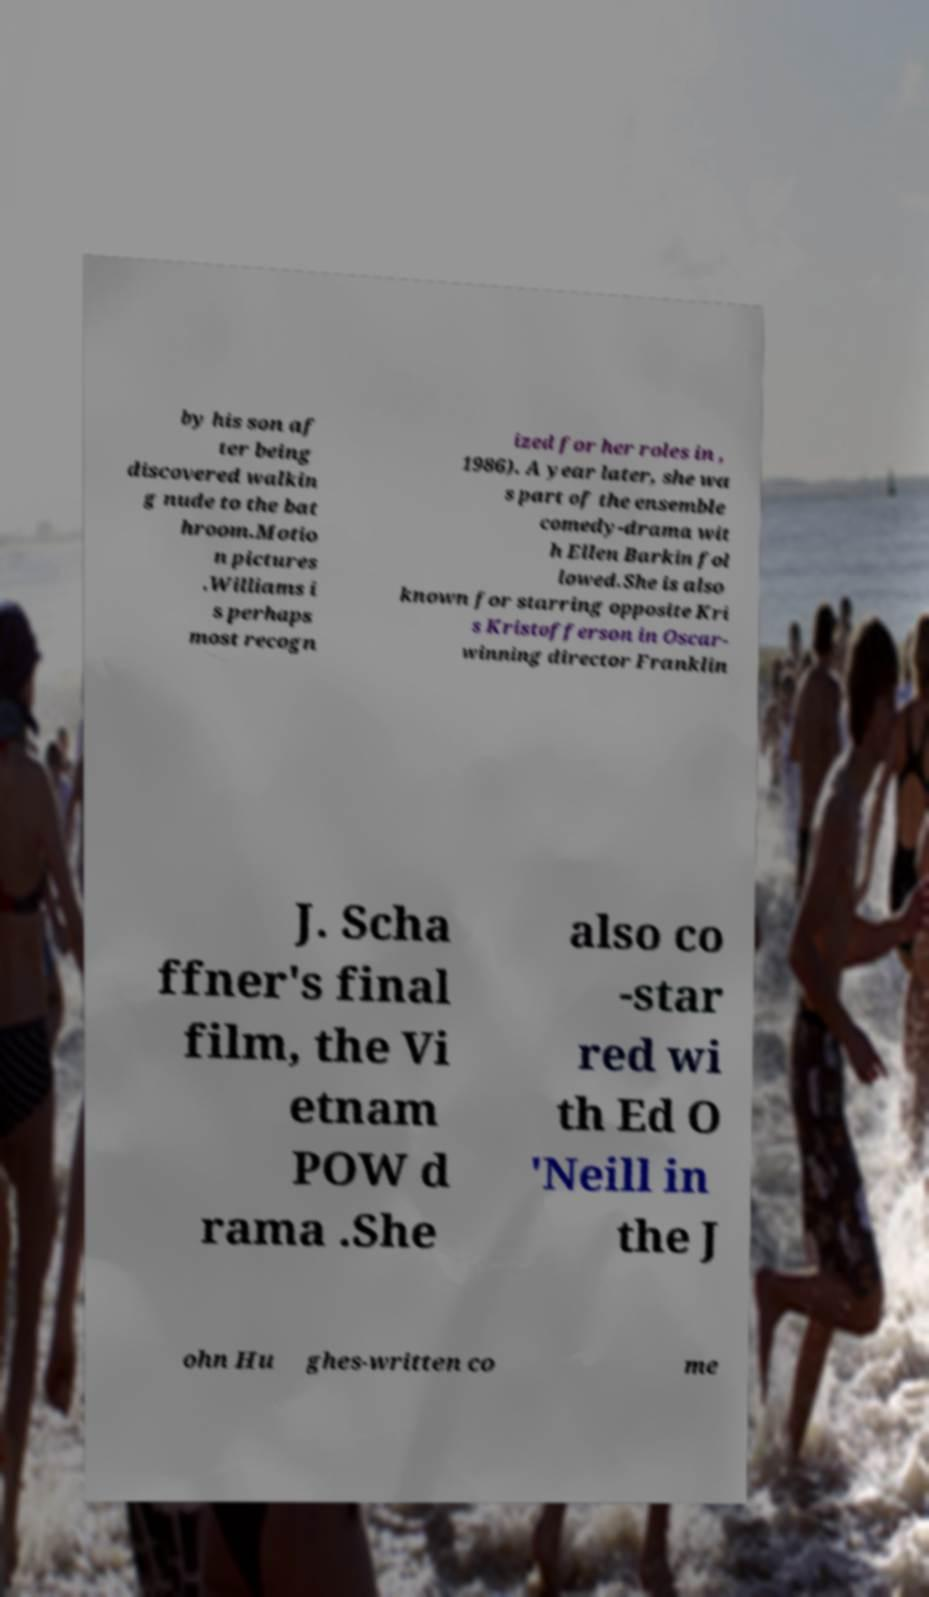Could you assist in decoding the text presented in this image and type it out clearly? by his son af ter being discovered walkin g nude to the bat hroom.Motio n pictures .Williams i s perhaps most recogn ized for her roles in , 1986). A year later, she wa s part of the ensemble comedy-drama wit h Ellen Barkin fol lowed.She is also known for starring opposite Kri s Kristofferson in Oscar- winning director Franklin J. Scha ffner's final film, the Vi etnam POW d rama .She also co -star red wi th Ed O 'Neill in the J ohn Hu ghes-written co me 